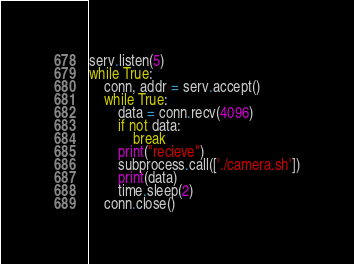<code> <loc_0><loc_0><loc_500><loc_500><_Python_>serv.listen(5)
while True:
    conn, addr = serv.accept()
    while True:
        data = conn.recv(4096)
        if not data:
            break
        print("recieve")
        subprocess.call(['./camera.sh'])
        print(data)
        time.sleep(2)
    conn.close()
</code> 